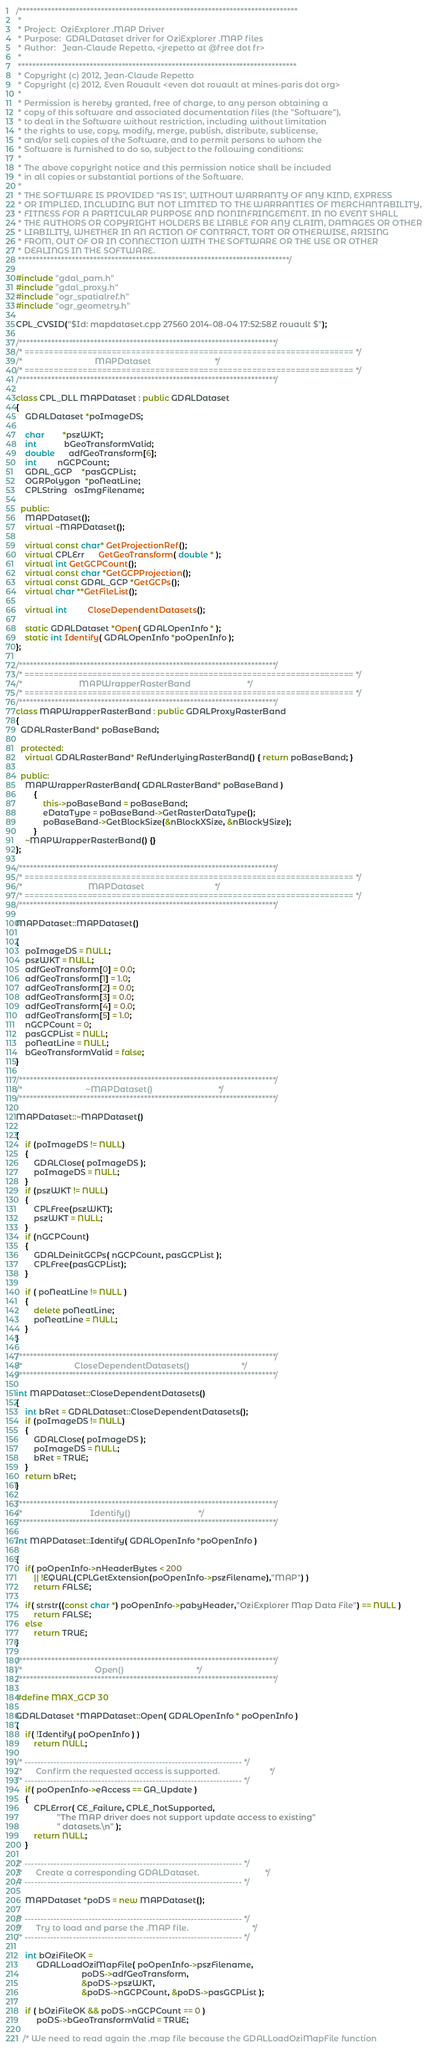Convert code to text. <code><loc_0><loc_0><loc_500><loc_500><_C++_>/******************************************************************************
 *
 * Project:  OziExplorer .MAP Driver
 * Purpose:  GDALDataset driver for OziExplorer .MAP files
 * Author:   Jean-Claude Repetto, <jrepetto at @free dot fr>
 *
 ******************************************************************************
 * Copyright (c) 2012, Jean-Claude Repetto
 * Copyright (c) 2012, Even Rouault <even dot rouault at mines-paris dot org>
 *
 * Permission is hereby granted, free of charge, to any person obtaining a
 * copy of this software and associated documentation files (the "Software"),
 * to deal in the Software without restriction, including without limitation
 * the rights to use, copy, modify, merge, publish, distribute, sublicense,
 * and/or sell copies of the Software, and to permit persons to whom the
 * Software is furnished to do so, subject to the following conditions:
 *
 * The above copyright notice and this permission notice shall be included
 * in all copies or substantial portions of the Software.
 *
 * THE SOFTWARE IS PROVIDED "AS IS", WITHOUT WARRANTY OF ANY KIND, EXPRESS
 * OR IMPLIED, INCLUDING BUT NOT LIMITED TO THE WARRANTIES OF MERCHANTABILITY,
 * FITNESS FOR A PARTICULAR PURPOSE AND NONINFRINGEMENT. IN NO EVENT SHALL
 * THE AUTHORS OR COPYRIGHT HOLDERS BE LIABLE FOR ANY CLAIM, DAMAGES OR OTHER
 * LIABILITY, WHETHER IN AN ACTION OF CONTRACT, TORT OR OTHERWISE, ARISING
 * FROM, OUT OF OR IN CONNECTION WITH THE SOFTWARE OR THE USE OR OTHER
 * DEALINGS IN THE SOFTWARE.
 ****************************************************************************/

#include "gdal_pam.h"
#include "gdal_proxy.h"
#include "ogr_spatialref.h"
#include "ogr_geometry.h"

CPL_CVSID("$Id: mapdataset.cpp 27560 2014-08-04 17:52:58Z rouault $");

/************************************************************************/
/* ==================================================================== */
/*                                MAPDataset                            */
/* ==================================================================== */
/************************************************************************/

class CPL_DLL MAPDataset : public GDALDataset
{
    GDALDataset *poImageDS;

    char        *pszWKT;
    int	        bGeoTransformValid;
    double      adfGeoTransform[6];
    int         nGCPCount;
    GDAL_GCP	*pasGCPList;
    OGRPolygon  *poNeatLine;
    CPLString   osImgFilename;

  public:
    MAPDataset();
    virtual ~MAPDataset();

    virtual const char* GetProjectionRef();
    virtual CPLErr      GetGeoTransform( double * );
    virtual int GetGCPCount();
    virtual const char *GetGCPProjection();
    virtual const GDAL_GCP *GetGCPs();
    virtual char **GetFileList();

    virtual int         CloseDependentDatasets();

    static GDALDataset *Open( GDALOpenInfo * );
    static int Identify( GDALOpenInfo *poOpenInfo );
};

/************************************************************************/
/* ==================================================================== */
/*                         MAPWrapperRasterBand                         */
/* ==================================================================== */
/************************************************************************/
class MAPWrapperRasterBand : public GDALProxyRasterBand
{
  GDALRasterBand* poBaseBand;

  protected:
    virtual GDALRasterBand* RefUnderlyingRasterBand() { return poBaseBand; }

  public:
    MAPWrapperRasterBand( GDALRasterBand* poBaseBand )
        {
            this->poBaseBand = poBaseBand;
            eDataType = poBaseBand->GetRasterDataType();
            poBaseBand->GetBlockSize(&nBlockXSize, &nBlockYSize);
        }
    ~MAPWrapperRasterBand() {}
};

/************************************************************************/
/* ==================================================================== */
/*                             MAPDataset                               */
/* ==================================================================== */
/************************************************************************/

MAPDataset::MAPDataset()

{
    poImageDS = NULL;
    pszWKT = NULL;
    adfGeoTransform[0] = 0.0;
    adfGeoTransform[1] = 1.0;
    adfGeoTransform[2] = 0.0;
    adfGeoTransform[3] = 0.0;
    adfGeoTransform[4] = 0.0;
    adfGeoTransform[5] = 1.0;
    nGCPCount = 0;
    pasGCPList = NULL;
    poNeatLine = NULL;
    bGeoTransformValid = false;
}

/************************************************************************/
/*                            ~MAPDataset()                             */
/************************************************************************/

MAPDataset::~MAPDataset()

{
    if (poImageDS != NULL)
    {
        GDALClose( poImageDS );
        poImageDS = NULL;
    }
    if (pszWKT != NULL)
    {
        CPLFree(pszWKT);
        pszWKT = NULL;
    }
    if (nGCPCount)
    {
        GDALDeinitGCPs( nGCPCount, pasGCPList );
        CPLFree(pasGCPList);
    }

    if ( poNeatLine != NULL )
    {
        delete poNeatLine;
        poNeatLine = NULL;
    }
}

/************************************************************************/
/*                       CloseDependentDatasets()                       */
/************************************************************************/

int MAPDataset::CloseDependentDatasets()
{
    int bRet = GDALDataset::CloseDependentDatasets();
    if (poImageDS != NULL)
    {
        GDALClose( poImageDS );
        poImageDS = NULL;
        bRet = TRUE;
    }
    return bRet;
}

/************************************************************************/
/*                              Identify()                              */
/************************************************************************/

int MAPDataset::Identify( GDALOpenInfo *poOpenInfo )

{
    if( poOpenInfo->nHeaderBytes < 200 
        || !EQUAL(CPLGetExtension(poOpenInfo->pszFilename),"MAP") )
        return FALSE;

    if( strstr((const char *) poOpenInfo->pabyHeader,"OziExplorer Map Data File") == NULL )
        return FALSE;
    else
        return TRUE;
}

/************************************************************************/
/*                                Open()                                */
/************************************************************************/

#define MAX_GCP 30

GDALDataset *MAPDataset::Open( GDALOpenInfo * poOpenInfo )
{
    if( !Identify( poOpenInfo ) )
        return NULL;

/* -------------------------------------------------------------------- */
/*      Confirm the requested access is supported.                      */
/* -------------------------------------------------------------------- */
    if( poOpenInfo->eAccess == GA_Update )
    {
        CPLError( CE_Failure, CPLE_NotSupported, 
                  "The MAP driver does not support update access to existing"
                  " datasets.\n" );
        return NULL;
    }
    
/* -------------------------------------------------------------------- */
/*      Create a corresponding GDALDataset.                             */
/* -------------------------------------------------------------------- */

    MAPDataset *poDS = new MAPDataset();

/* -------------------------------------------------------------------- */
/*      Try to load and parse the .MAP file.                            */
/* -------------------------------------------------------------------- */

    int bOziFileOK = 
         GDALLoadOziMapFile( poOpenInfo->pszFilename,
                             poDS->adfGeoTransform, 
                             &poDS->pszWKT,
                             &poDS->nGCPCount, &poDS->pasGCPList );

    if ( bOziFileOK && poDS->nGCPCount == 0 )
         poDS->bGeoTransformValid = TRUE;

   /* We need to read again the .map file because the GDALLoadOziMapFile function</code> 